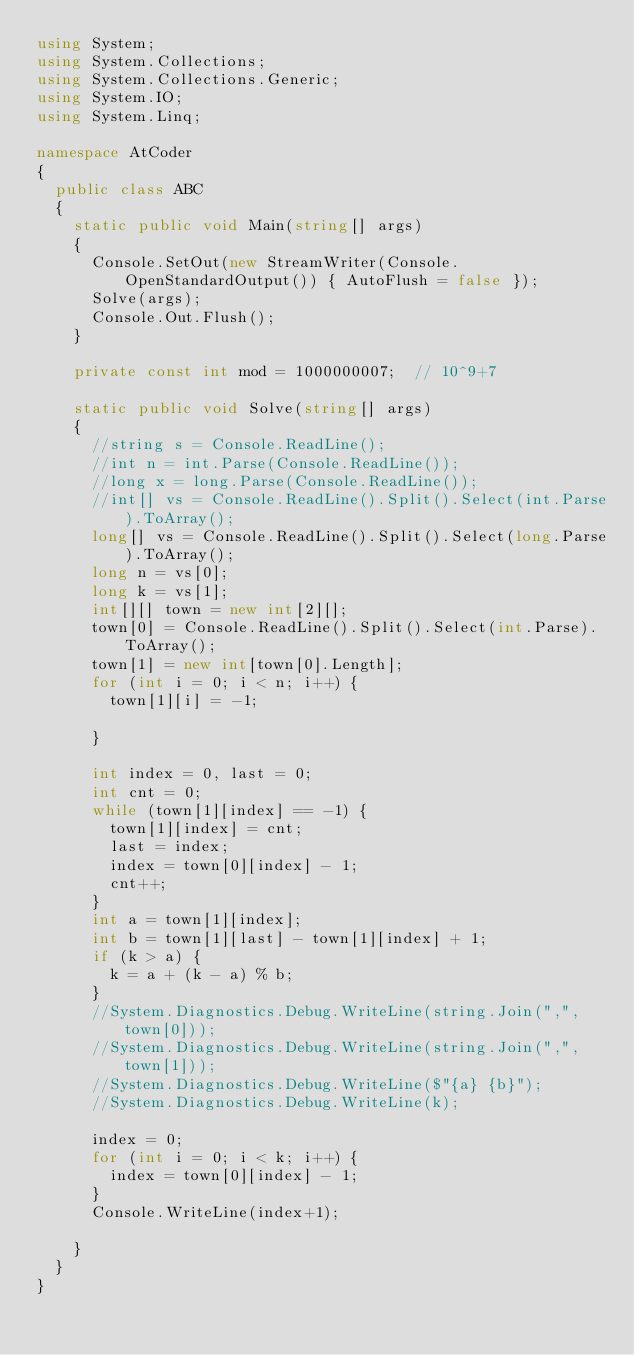<code> <loc_0><loc_0><loc_500><loc_500><_C#_>using System;
using System.Collections;
using System.Collections.Generic;
using System.IO;
using System.Linq;

namespace AtCoder
{
	public class ABC
	{
		static public void Main(string[] args)
		{
			Console.SetOut(new StreamWriter(Console.OpenStandardOutput()) { AutoFlush = false });
			Solve(args);
			Console.Out.Flush();
		}

		private const int mod = 1000000007;  // 10^9+7

		static public void Solve(string[] args)
		{
			//string s = Console.ReadLine();
			//int n = int.Parse(Console.ReadLine());
			//long x = long.Parse(Console.ReadLine());
			//int[] vs = Console.ReadLine().Split().Select(int.Parse).ToArray();
			long[] vs = Console.ReadLine().Split().Select(long.Parse).ToArray();
			long n = vs[0];
			long k = vs[1];
			int[][] town = new int[2][];
			town[0] = Console.ReadLine().Split().Select(int.Parse).ToArray();
			town[1] = new int[town[0].Length];
			for (int i = 0; i < n; i++) {
				town[1][i] = -1;

			}

			int index = 0, last = 0;
			int cnt = 0;
			while (town[1][index] == -1) {
				town[1][index] = cnt;
				last = index;
				index = town[0][index] - 1;
				cnt++;
			}
			int a = town[1][index];
			int b = town[1][last] - town[1][index] + 1;
			if (k > a) {
				k = a + (k - a) % b;
			}
			//System.Diagnostics.Debug.WriteLine(string.Join(",", town[0]));
			//System.Diagnostics.Debug.WriteLine(string.Join(",", town[1]));
			//System.Diagnostics.Debug.WriteLine($"{a} {b}");
			//System.Diagnostics.Debug.WriteLine(k);

			index = 0;
			for (int i = 0; i < k; i++) {
				index = town[0][index] - 1;
			}
			Console.WriteLine(index+1);

		}
	}
}
</code> 